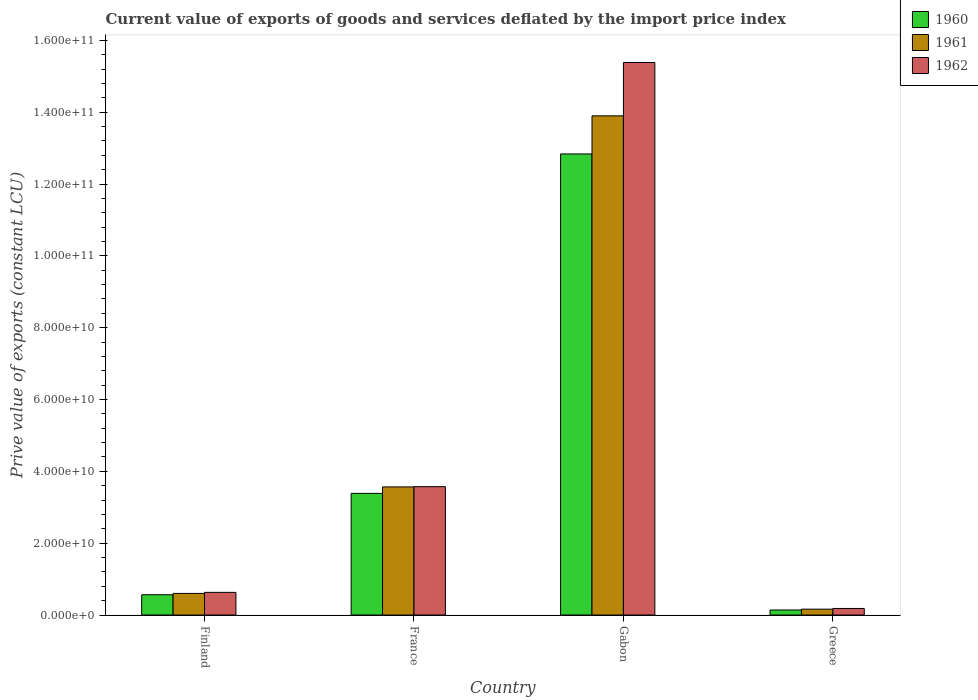How many groups of bars are there?
Make the answer very short. 4. Are the number of bars per tick equal to the number of legend labels?
Provide a succinct answer. Yes. Are the number of bars on each tick of the X-axis equal?
Provide a short and direct response. Yes. What is the label of the 3rd group of bars from the left?
Make the answer very short. Gabon. What is the prive value of exports in 1961 in Finland?
Provide a succinct answer. 6.02e+09. Across all countries, what is the maximum prive value of exports in 1960?
Your answer should be very brief. 1.28e+11. Across all countries, what is the minimum prive value of exports in 1961?
Offer a terse response. 1.63e+09. In which country was the prive value of exports in 1961 maximum?
Your answer should be compact. Gabon. In which country was the prive value of exports in 1960 minimum?
Provide a short and direct response. Greece. What is the total prive value of exports in 1961 in the graph?
Offer a very short reply. 1.82e+11. What is the difference between the prive value of exports in 1961 in Finland and that in Gabon?
Give a very brief answer. -1.33e+11. What is the difference between the prive value of exports in 1961 in Gabon and the prive value of exports in 1962 in Finland?
Provide a succinct answer. 1.33e+11. What is the average prive value of exports in 1961 per country?
Offer a terse response. 4.56e+1. What is the difference between the prive value of exports of/in 1960 and prive value of exports of/in 1961 in Gabon?
Keep it short and to the point. -1.06e+1. In how many countries, is the prive value of exports in 1961 greater than 116000000000 LCU?
Your answer should be very brief. 1. What is the ratio of the prive value of exports in 1962 in Gabon to that in Greece?
Your response must be concise. 84.26. Is the difference between the prive value of exports in 1960 in Gabon and Greece greater than the difference between the prive value of exports in 1961 in Gabon and Greece?
Give a very brief answer. No. What is the difference between the highest and the second highest prive value of exports in 1961?
Keep it short and to the point. -2.97e+1. What is the difference between the highest and the lowest prive value of exports in 1962?
Make the answer very short. 1.52e+11. What does the 1st bar from the left in Gabon represents?
Your answer should be compact. 1960. What does the 3rd bar from the right in Greece represents?
Keep it short and to the point. 1960. Is it the case that in every country, the sum of the prive value of exports in 1961 and prive value of exports in 1962 is greater than the prive value of exports in 1960?
Ensure brevity in your answer.  Yes. How many bars are there?
Give a very brief answer. 12. Are all the bars in the graph horizontal?
Your answer should be very brief. No. What is the difference between two consecutive major ticks on the Y-axis?
Provide a short and direct response. 2.00e+1. Does the graph contain any zero values?
Give a very brief answer. No. Does the graph contain grids?
Your answer should be compact. No. What is the title of the graph?
Make the answer very short. Current value of exports of goods and services deflated by the import price index. Does "1979" appear as one of the legend labels in the graph?
Give a very brief answer. No. What is the label or title of the X-axis?
Your response must be concise. Country. What is the label or title of the Y-axis?
Your response must be concise. Prive value of exports (constant LCU). What is the Prive value of exports (constant LCU) of 1960 in Finland?
Your answer should be compact. 5.65e+09. What is the Prive value of exports (constant LCU) in 1961 in Finland?
Your answer should be very brief. 6.02e+09. What is the Prive value of exports (constant LCU) in 1962 in Finland?
Your answer should be very brief. 6.31e+09. What is the Prive value of exports (constant LCU) in 1960 in France?
Offer a very short reply. 3.39e+1. What is the Prive value of exports (constant LCU) of 1961 in France?
Your response must be concise. 3.57e+1. What is the Prive value of exports (constant LCU) in 1962 in France?
Provide a succinct answer. 3.57e+1. What is the Prive value of exports (constant LCU) in 1960 in Gabon?
Offer a very short reply. 1.28e+11. What is the Prive value of exports (constant LCU) of 1961 in Gabon?
Your response must be concise. 1.39e+11. What is the Prive value of exports (constant LCU) of 1962 in Gabon?
Make the answer very short. 1.54e+11. What is the Prive value of exports (constant LCU) of 1960 in Greece?
Give a very brief answer. 1.40e+09. What is the Prive value of exports (constant LCU) of 1961 in Greece?
Offer a very short reply. 1.63e+09. What is the Prive value of exports (constant LCU) in 1962 in Greece?
Offer a terse response. 1.83e+09. Across all countries, what is the maximum Prive value of exports (constant LCU) of 1960?
Provide a succinct answer. 1.28e+11. Across all countries, what is the maximum Prive value of exports (constant LCU) of 1961?
Give a very brief answer. 1.39e+11. Across all countries, what is the maximum Prive value of exports (constant LCU) in 1962?
Your response must be concise. 1.54e+11. Across all countries, what is the minimum Prive value of exports (constant LCU) of 1960?
Make the answer very short. 1.40e+09. Across all countries, what is the minimum Prive value of exports (constant LCU) of 1961?
Offer a terse response. 1.63e+09. Across all countries, what is the minimum Prive value of exports (constant LCU) of 1962?
Offer a terse response. 1.83e+09. What is the total Prive value of exports (constant LCU) in 1960 in the graph?
Your answer should be compact. 1.69e+11. What is the total Prive value of exports (constant LCU) of 1961 in the graph?
Provide a short and direct response. 1.82e+11. What is the total Prive value of exports (constant LCU) of 1962 in the graph?
Your answer should be very brief. 1.98e+11. What is the difference between the Prive value of exports (constant LCU) in 1960 in Finland and that in France?
Ensure brevity in your answer.  -2.82e+1. What is the difference between the Prive value of exports (constant LCU) in 1961 in Finland and that in France?
Offer a very short reply. -2.97e+1. What is the difference between the Prive value of exports (constant LCU) of 1962 in Finland and that in France?
Your answer should be compact. -2.94e+1. What is the difference between the Prive value of exports (constant LCU) in 1960 in Finland and that in Gabon?
Offer a very short reply. -1.23e+11. What is the difference between the Prive value of exports (constant LCU) in 1961 in Finland and that in Gabon?
Your answer should be very brief. -1.33e+11. What is the difference between the Prive value of exports (constant LCU) of 1962 in Finland and that in Gabon?
Ensure brevity in your answer.  -1.48e+11. What is the difference between the Prive value of exports (constant LCU) of 1960 in Finland and that in Greece?
Provide a succinct answer. 4.25e+09. What is the difference between the Prive value of exports (constant LCU) of 1961 in Finland and that in Greece?
Keep it short and to the point. 4.39e+09. What is the difference between the Prive value of exports (constant LCU) of 1962 in Finland and that in Greece?
Your answer should be very brief. 4.48e+09. What is the difference between the Prive value of exports (constant LCU) in 1960 in France and that in Gabon?
Provide a short and direct response. -9.45e+1. What is the difference between the Prive value of exports (constant LCU) of 1961 in France and that in Gabon?
Your answer should be very brief. -1.03e+11. What is the difference between the Prive value of exports (constant LCU) in 1962 in France and that in Gabon?
Provide a succinct answer. -1.18e+11. What is the difference between the Prive value of exports (constant LCU) of 1960 in France and that in Greece?
Your answer should be very brief. 3.25e+1. What is the difference between the Prive value of exports (constant LCU) in 1961 in France and that in Greece?
Offer a terse response. 3.40e+1. What is the difference between the Prive value of exports (constant LCU) of 1962 in France and that in Greece?
Your response must be concise. 3.39e+1. What is the difference between the Prive value of exports (constant LCU) in 1960 in Gabon and that in Greece?
Offer a very short reply. 1.27e+11. What is the difference between the Prive value of exports (constant LCU) of 1961 in Gabon and that in Greece?
Your answer should be compact. 1.37e+11. What is the difference between the Prive value of exports (constant LCU) in 1962 in Gabon and that in Greece?
Provide a short and direct response. 1.52e+11. What is the difference between the Prive value of exports (constant LCU) of 1960 in Finland and the Prive value of exports (constant LCU) of 1961 in France?
Provide a short and direct response. -3.00e+1. What is the difference between the Prive value of exports (constant LCU) of 1960 in Finland and the Prive value of exports (constant LCU) of 1962 in France?
Offer a very short reply. -3.01e+1. What is the difference between the Prive value of exports (constant LCU) in 1961 in Finland and the Prive value of exports (constant LCU) in 1962 in France?
Give a very brief answer. -2.97e+1. What is the difference between the Prive value of exports (constant LCU) of 1960 in Finland and the Prive value of exports (constant LCU) of 1961 in Gabon?
Provide a succinct answer. -1.33e+11. What is the difference between the Prive value of exports (constant LCU) in 1960 in Finland and the Prive value of exports (constant LCU) in 1962 in Gabon?
Your response must be concise. -1.48e+11. What is the difference between the Prive value of exports (constant LCU) in 1961 in Finland and the Prive value of exports (constant LCU) in 1962 in Gabon?
Provide a short and direct response. -1.48e+11. What is the difference between the Prive value of exports (constant LCU) in 1960 in Finland and the Prive value of exports (constant LCU) in 1961 in Greece?
Your answer should be very brief. 4.02e+09. What is the difference between the Prive value of exports (constant LCU) of 1960 in Finland and the Prive value of exports (constant LCU) of 1962 in Greece?
Offer a terse response. 3.82e+09. What is the difference between the Prive value of exports (constant LCU) of 1961 in Finland and the Prive value of exports (constant LCU) of 1962 in Greece?
Offer a terse response. 4.19e+09. What is the difference between the Prive value of exports (constant LCU) in 1960 in France and the Prive value of exports (constant LCU) in 1961 in Gabon?
Keep it short and to the point. -1.05e+11. What is the difference between the Prive value of exports (constant LCU) of 1960 in France and the Prive value of exports (constant LCU) of 1962 in Gabon?
Offer a terse response. -1.20e+11. What is the difference between the Prive value of exports (constant LCU) in 1961 in France and the Prive value of exports (constant LCU) in 1962 in Gabon?
Offer a very short reply. -1.18e+11. What is the difference between the Prive value of exports (constant LCU) in 1960 in France and the Prive value of exports (constant LCU) in 1961 in Greece?
Your answer should be compact. 3.22e+1. What is the difference between the Prive value of exports (constant LCU) in 1960 in France and the Prive value of exports (constant LCU) in 1962 in Greece?
Provide a succinct answer. 3.20e+1. What is the difference between the Prive value of exports (constant LCU) in 1961 in France and the Prive value of exports (constant LCU) in 1962 in Greece?
Provide a short and direct response. 3.38e+1. What is the difference between the Prive value of exports (constant LCU) in 1960 in Gabon and the Prive value of exports (constant LCU) in 1961 in Greece?
Offer a very short reply. 1.27e+11. What is the difference between the Prive value of exports (constant LCU) of 1960 in Gabon and the Prive value of exports (constant LCU) of 1962 in Greece?
Your answer should be very brief. 1.27e+11. What is the difference between the Prive value of exports (constant LCU) in 1961 in Gabon and the Prive value of exports (constant LCU) in 1962 in Greece?
Provide a short and direct response. 1.37e+11. What is the average Prive value of exports (constant LCU) of 1960 per country?
Offer a terse response. 4.23e+1. What is the average Prive value of exports (constant LCU) of 1961 per country?
Your answer should be very brief. 4.56e+1. What is the average Prive value of exports (constant LCU) in 1962 per country?
Provide a short and direct response. 4.94e+1. What is the difference between the Prive value of exports (constant LCU) in 1960 and Prive value of exports (constant LCU) in 1961 in Finland?
Provide a succinct answer. -3.69e+08. What is the difference between the Prive value of exports (constant LCU) in 1960 and Prive value of exports (constant LCU) in 1962 in Finland?
Offer a terse response. -6.62e+08. What is the difference between the Prive value of exports (constant LCU) in 1961 and Prive value of exports (constant LCU) in 1962 in Finland?
Keep it short and to the point. -2.93e+08. What is the difference between the Prive value of exports (constant LCU) of 1960 and Prive value of exports (constant LCU) of 1961 in France?
Offer a terse response. -1.80e+09. What is the difference between the Prive value of exports (constant LCU) of 1960 and Prive value of exports (constant LCU) of 1962 in France?
Offer a terse response. -1.87e+09. What is the difference between the Prive value of exports (constant LCU) of 1961 and Prive value of exports (constant LCU) of 1962 in France?
Provide a succinct answer. -6.74e+07. What is the difference between the Prive value of exports (constant LCU) of 1960 and Prive value of exports (constant LCU) of 1961 in Gabon?
Make the answer very short. -1.06e+1. What is the difference between the Prive value of exports (constant LCU) of 1960 and Prive value of exports (constant LCU) of 1962 in Gabon?
Your answer should be compact. -2.55e+1. What is the difference between the Prive value of exports (constant LCU) of 1961 and Prive value of exports (constant LCU) of 1962 in Gabon?
Give a very brief answer. -1.49e+1. What is the difference between the Prive value of exports (constant LCU) in 1960 and Prive value of exports (constant LCU) in 1961 in Greece?
Provide a short and direct response. -2.34e+08. What is the difference between the Prive value of exports (constant LCU) of 1960 and Prive value of exports (constant LCU) of 1962 in Greece?
Your answer should be very brief. -4.29e+08. What is the difference between the Prive value of exports (constant LCU) in 1961 and Prive value of exports (constant LCU) in 1962 in Greece?
Your answer should be very brief. -1.95e+08. What is the ratio of the Prive value of exports (constant LCU) in 1960 in Finland to that in France?
Offer a very short reply. 0.17. What is the ratio of the Prive value of exports (constant LCU) in 1961 in Finland to that in France?
Your response must be concise. 0.17. What is the ratio of the Prive value of exports (constant LCU) of 1962 in Finland to that in France?
Your response must be concise. 0.18. What is the ratio of the Prive value of exports (constant LCU) in 1960 in Finland to that in Gabon?
Provide a succinct answer. 0.04. What is the ratio of the Prive value of exports (constant LCU) in 1961 in Finland to that in Gabon?
Make the answer very short. 0.04. What is the ratio of the Prive value of exports (constant LCU) of 1962 in Finland to that in Gabon?
Make the answer very short. 0.04. What is the ratio of the Prive value of exports (constant LCU) in 1960 in Finland to that in Greece?
Offer a very short reply. 4.04. What is the ratio of the Prive value of exports (constant LCU) of 1961 in Finland to that in Greece?
Your answer should be very brief. 3.69. What is the ratio of the Prive value of exports (constant LCU) of 1962 in Finland to that in Greece?
Ensure brevity in your answer.  3.46. What is the ratio of the Prive value of exports (constant LCU) in 1960 in France to that in Gabon?
Provide a succinct answer. 0.26. What is the ratio of the Prive value of exports (constant LCU) of 1961 in France to that in Gabon?
Offer a terse response. 0.26. What is the ratio of the Prive value of exports (constant LCU) in 1962 in France to that in Gabon?
Offer a very short reply. 0.23. What is the ratio of the Prive value of exports (constant LCU) of 1960 in France to that in Greece?
Offer a terse response. 24.25. What is the ratio of the Prive value of exports (constant LCU) of 1961 in France to that in Greece?
Give a very brief answer. 21.88. What is the ratio of the Prive value of exports (constant LCU) of 1962 in France to that in Greece?
Keep it short and to the point. 19.57. What is the ratio of the Prive value of exports (constant LCU) in 1960 in Gabon to that in Greece?
Provide a succinct answer. 91.91. What is the ratio of the Prive value of exports (constant LCU) in 1961 in Gabon to that in Greece?
Give a very brief answer. 85.24. What is the ratio of the Prive value of exports (constant LCU) of 1962 in Gabon to that in Greece?
Your response must be concise. 84.26. What is the difference between the highest and the second highest Prive value of exports (constant LCU) of 1960?
Your answer should be compact. 9.45e+1. What is the difference between the highest and the second highest Prive value of exports (constant LCU) of 1961?
Ensure brevity in your answer.  1.03e+11. What is the difference between the highest and the second highest Prive value of exports (constant LCU) of 1962?
Offer a terse response. 1.18e+11. What is the difference between the highest and the lowest Prive value of exports (constant LCU) in 1960?
Your response must be concise. 1.27e+11. What is the difference between the highest and the lowest Prive value of exports (constant LCU) in 1961?
Provide a short and direct response. 1.37e+11. What is the difference between the highest and the lowest Prive value of exports (constant LCU) of 1962?
Give a very brief answer. 1.52e+11. 